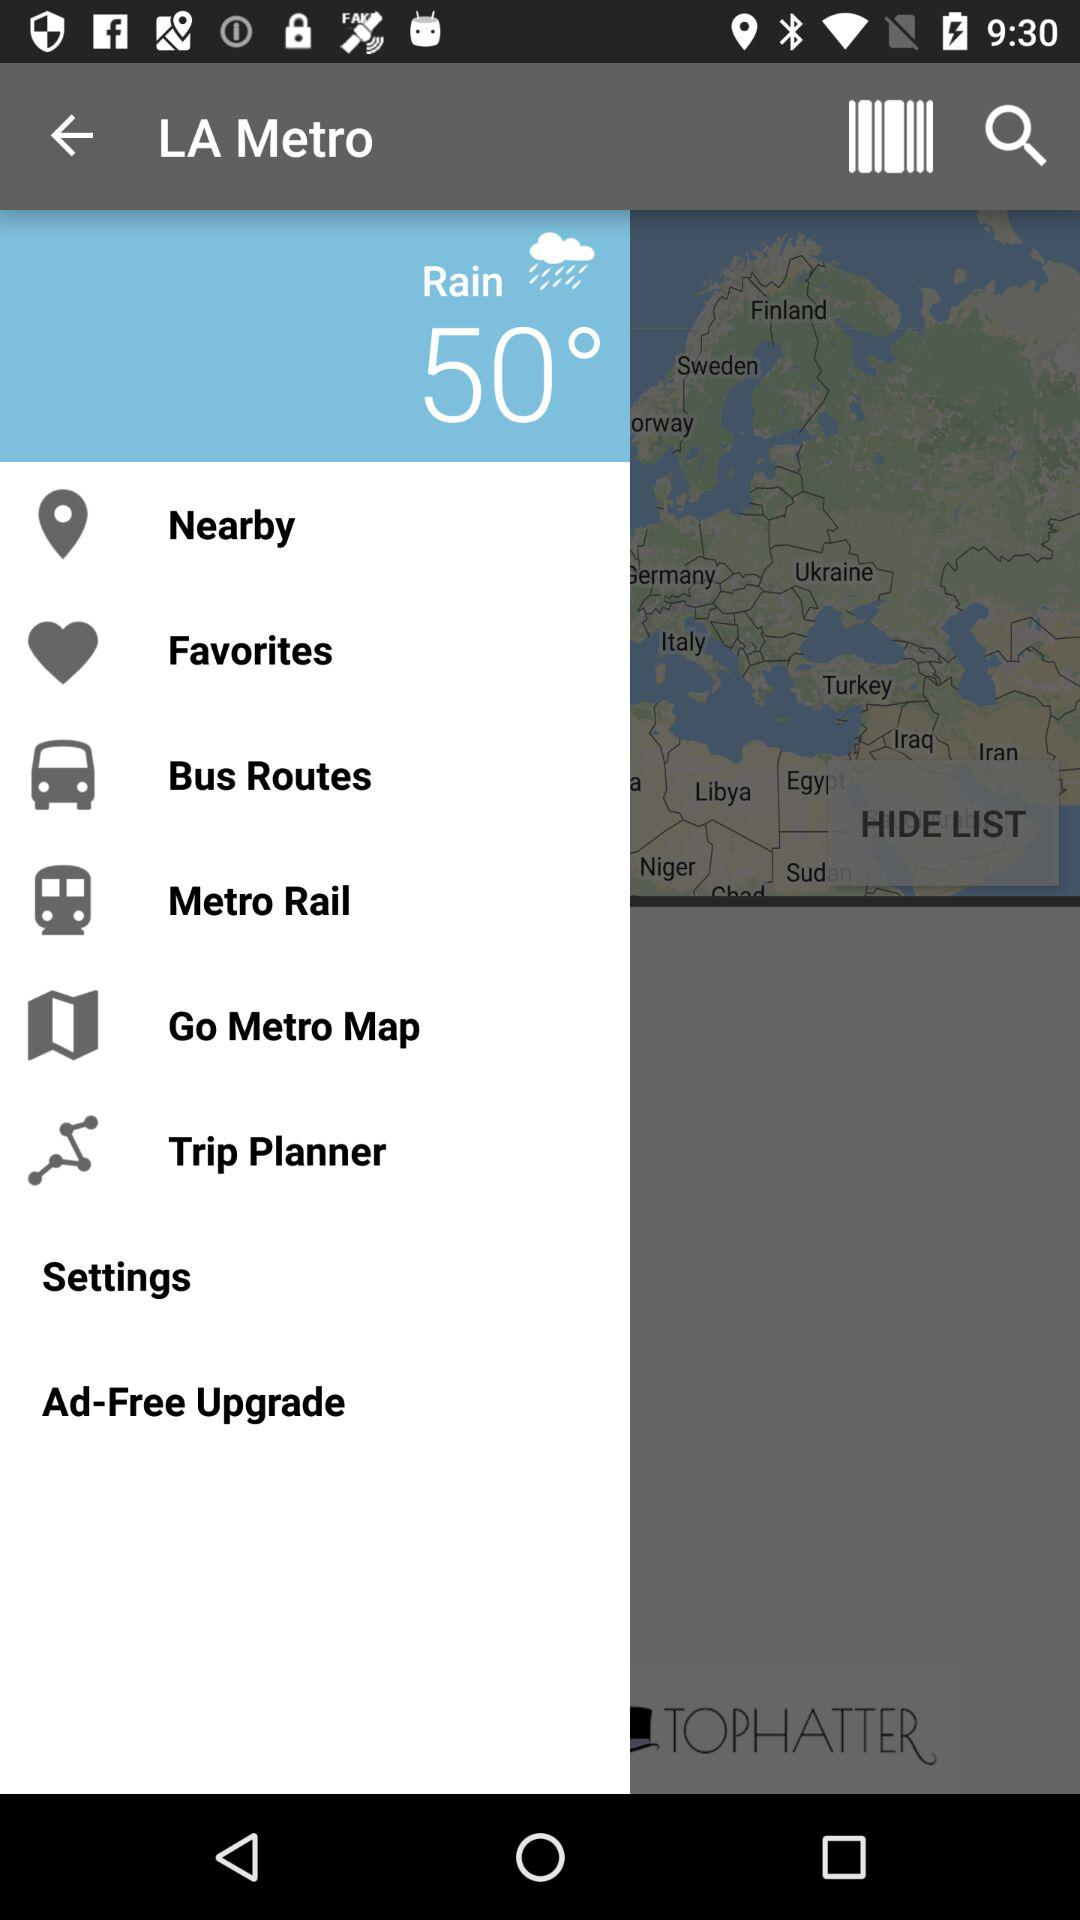What is the temperature? The temperature is 50°. 